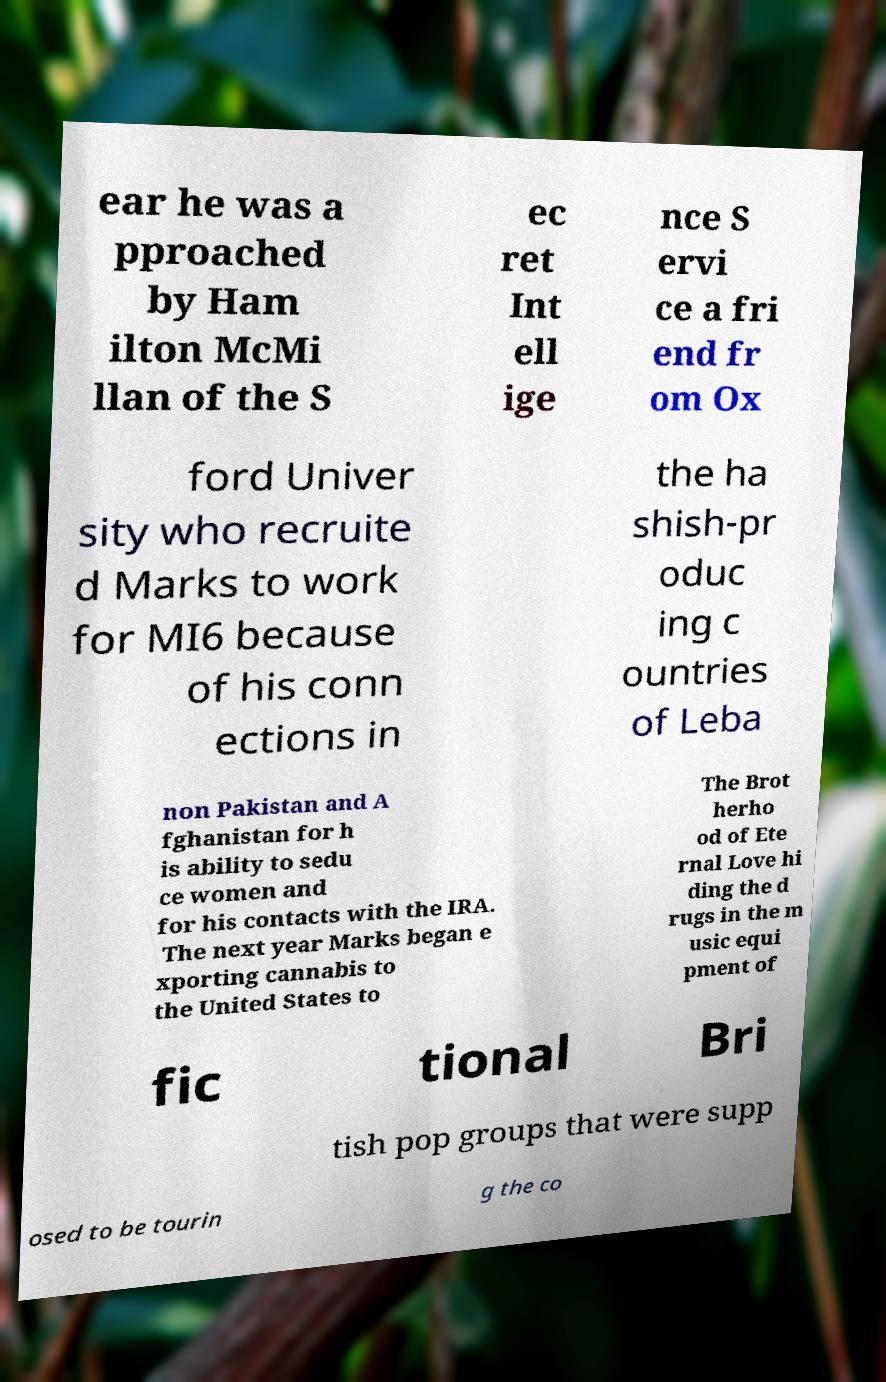There's text embedded in this image that I need extracted. Can you transcribe it verbatim? ear he was a pproached by Ham ilton McMi llan of the S ec ret Int ell ige nce S ervi ce a fri end fr om Ox ford Univer sity who recruite d Marks to work for MI6 because of his conn ections in the ha shish-pr oduc ing c ountries of Leba non Pakistan and A fghanistan for h is ability to sedu ce women and for his contacts with the IRA. The next year Marks began e xporting cannabis to the United States to The Brot herho od of Ete rnal Love hi ding the d rugs in the m usic equi pment of fic tional Bri tish pop groups that were supp osed to be tourin g the co 